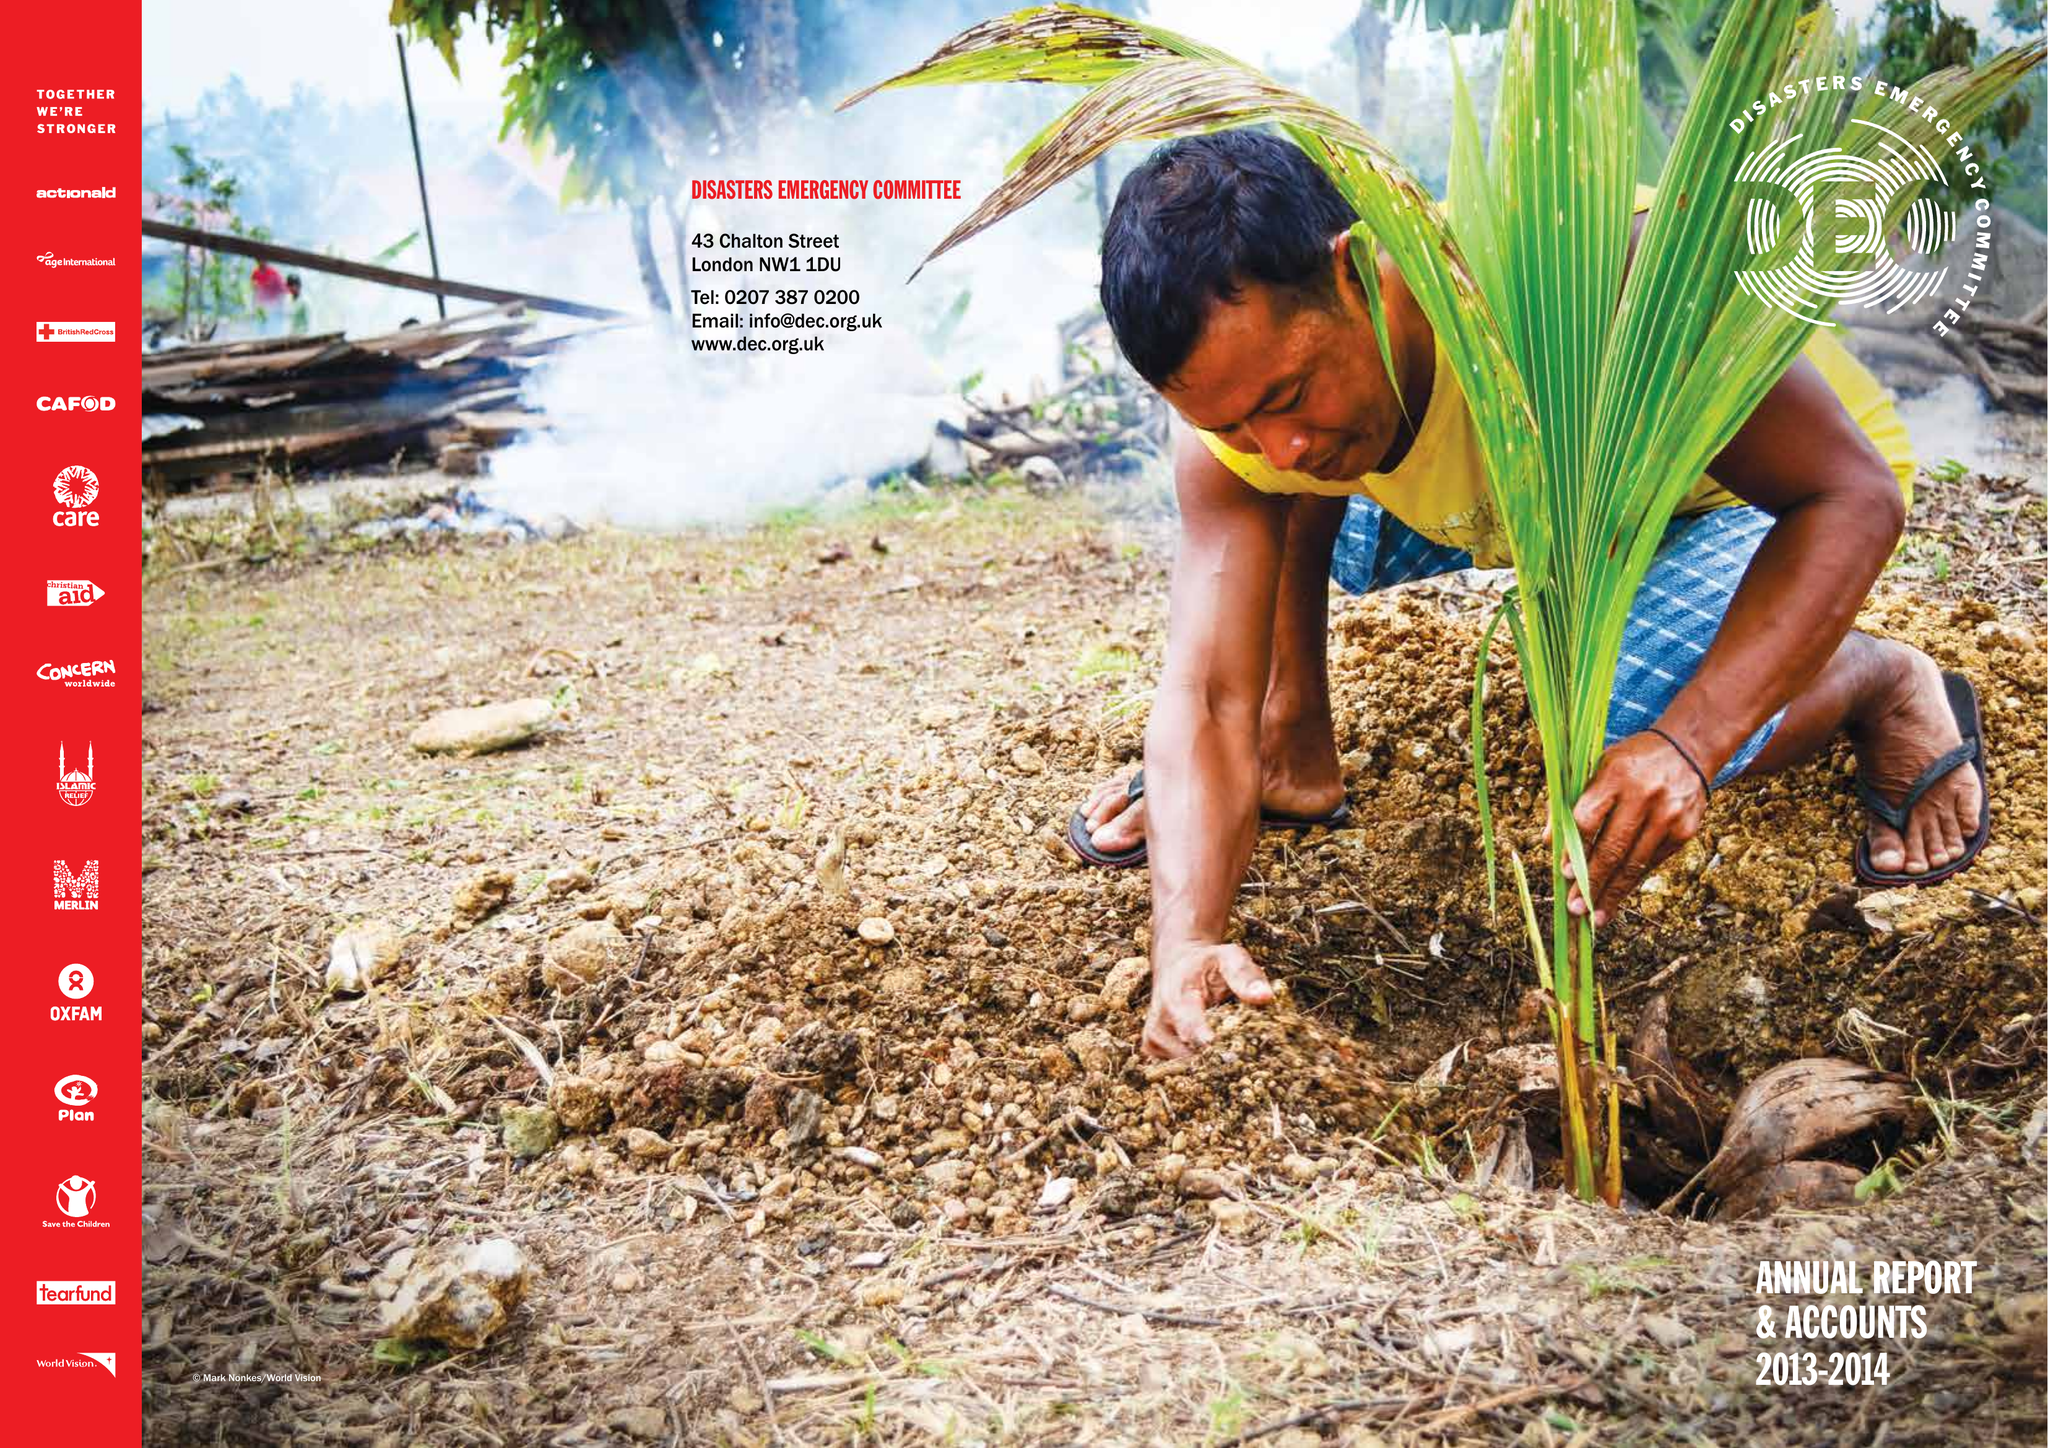What is the value for the charity_number?
Answer the question using a single word or phrase. 1062638 